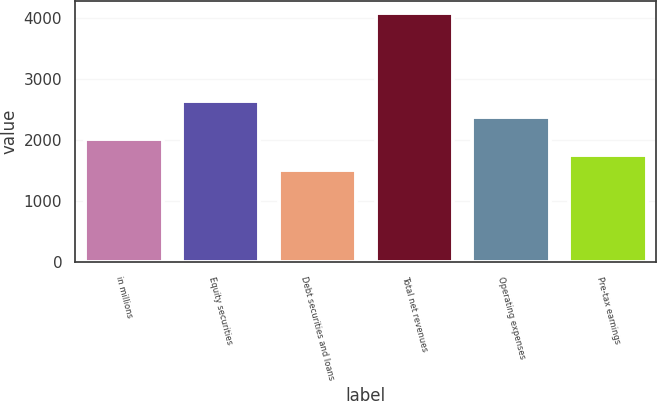Convert chart to OTSL. <chart><loc_0><loc_0><loc_500><loc_500><bar_chart><fcel>in millions<fcel>Equity securities<fcel>Debt securities and loans<fcel>Total net revenues<fcel>Operating expenses<fcel>Pre-tax earnings<nl><fcel>2021.6<fcel>2643.3<fcel>1507<fcel>4080<fcel>2386<fcel>1764.3<nl></chart> 